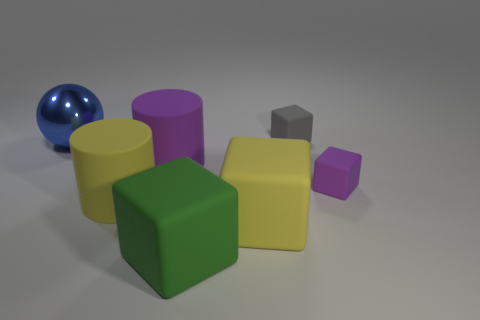Subtract 1 blocks. How many blocks are left? 3 Add 3 small matte objects. How many objects exist? 10 Subtract all cubes. How many objects are left? 3 Subtract 0 cyan spheres. How many objects are left? 7 Subtract all small purple blocks. Subtract all small green rubber spheres. How many objects are left? 6 Add 7 yellow cubes. How many yellow cubes are left? 8 Add 3 large spheres. How many large spheres exist? 4 